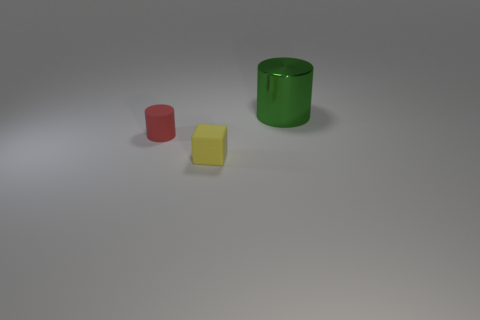What is the size of the cylinder in front of the green cylinder?
Provide a succinct answer. Small. What shape is the small object left of the small object that is in front of the small red cylinder?
Offer a terse response. Cylinder. There is another big thing that is the same shape as the red matte object; what is its color?
Offer a very short reply. Green. Is the size of the object that is on the left side of the yellow block the same as the tiny yellow block?
Your answer should be compact. Yes. How many large cylinders have the same material as the red object?
Your answer should be very brief. 0. What material is the cylinder that is in front of the big cylinder that is to the right of the cylinder that is left of the big metal thing made of?
Your answer should be very brief. Rubber. There is a big cylinder to the right of the cylinder that is left of the large green shiny cylinder; what color is it?
Your answer should be very brief. Green. There is a cube that is the same size as the matte cylinder; what color is it?
Your response must be concise. Yellow. How many tiny objects are green cylinders or purple rubber things?
Offer a terse response. 0. Are there more large metallic cylinders in front of the tiny red thing than green cylinders that are in front of the shiny cylinder?
Make the answer very short. No. 